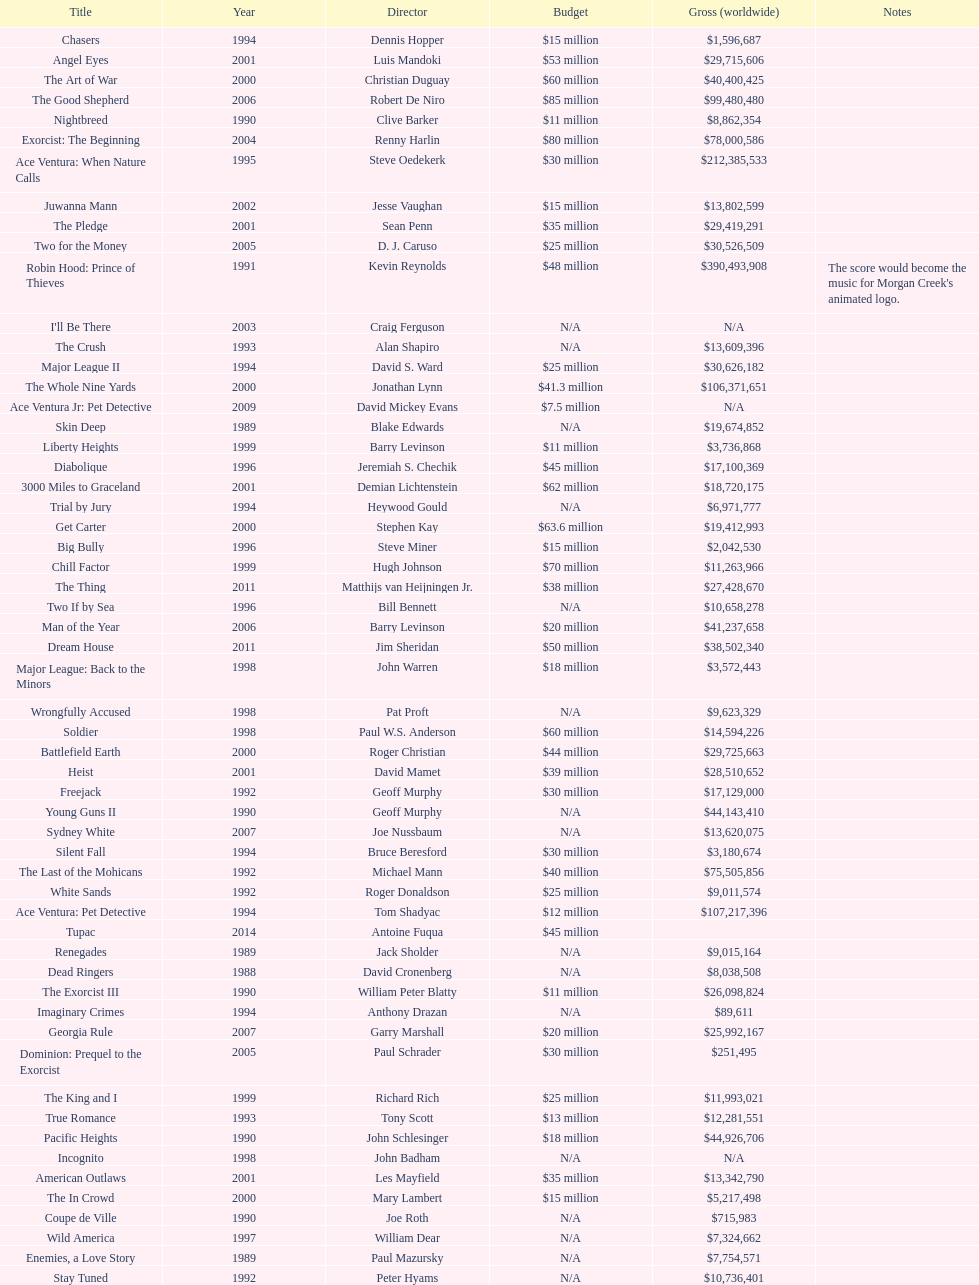After young guns, what was the next movie with the exact same budget? Major League. 